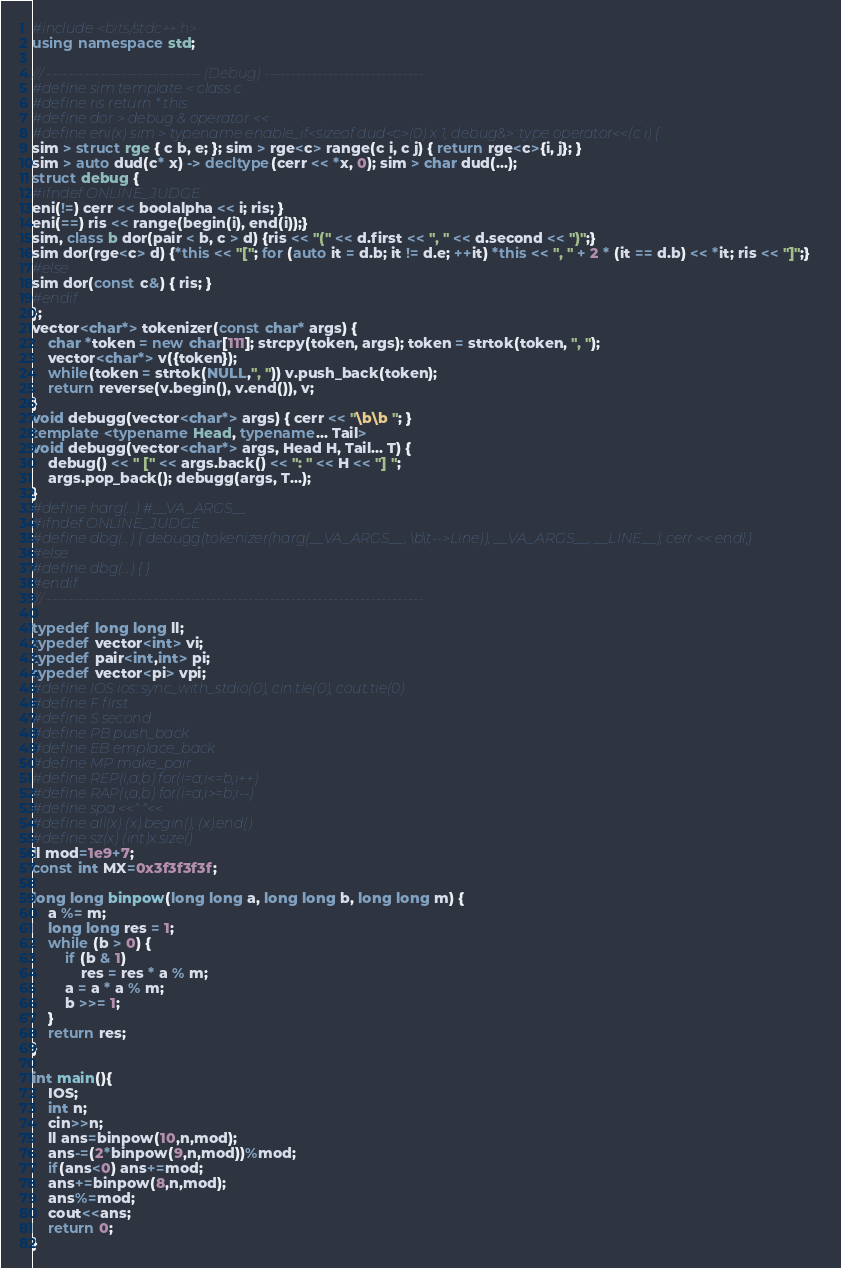<code> <loc_0><loc_0><loc_500><loc_500><_C++_>#include<bits/stdc++.h>
using namespace std;
 
/// ----------------------------- (Debug) ------------------------------
#define sim template < class c
#define ris return * this
#define dor > debug & operator <<
#define eni(x) sim > typename enable_if<sizeof dud<c>(0) x 1, debug&>::type operator<<(c i) {
sim > struct rge { c b, e; }; sim > rge<c> range(c i, c j) { return rge<c>{i, j}; }
sim > auto dud(c* x) -> decltype(cerr << *x, 0); sim > char dud(...);
struct debug {
#ifndef ONLINE_JUDGE
eni(!=) cerr << boolalpha << i; ris; }
eni(==) ris << range(begin(i), end(i));}
sim, class b dor(pair < b, c > d) {ris << "(" << d.first << ", " << d.second << ")";}
sim dor(rge<c> d) {*this << "["; for (auto it = d.b; it != d.e; ++it) *this << ", " + 2 * (it == d.b) << *it; ris << "]";}
#else
sim dor(const c&) { ris; }
#endif
};
vector<char*> tokenizer(const char* args) {
    char *token = new char[111]; strcpy(token, args); token = strtok(token, ", ");
    vector<char*> v({token});
    while(token = strtok(NULL,", ")) v.push_back(token);
    return reverse(v.begin(), v.end()), v;
}
void debugg(vector<char*> args) { cerr << "\b\b "; }
template <typename Head, typename... Tail>
void debugg(vector<char*> args, Head H, Tail... T) {
    debug() << " [" << args.back() << ": " << H << "] ";
    args.pop_back(); debugg(args, T...);
}
#define harg(...) #__VA_ARGS__
#ifndef ONLINE_JUDGE
#define dbg(...) { debugg(tokenizer(harg(__VA_ARGS__, \b\t-->Line)), __VA_ARGS__, __LINE__); cerr << endl;}
#else
#define dbg(...) { }
#endif
/// -----------------------------------------------------------------------
 
typedef long long ll;
typedef vector<int> vi;
typedef pair<int,int> pi;
typedef vector<pi> vpi; 
#define IOS ios::sync_with_stdio(0); cin.tie(0); cout.tie(0)    
#define F first
#define S second
#define PB push_back
#define EB emplace_back
#define MP make_pair
#define REP(i,a,b) for(i=a;i<=b;i++)
#define RAP(i,a,b) for(i=a;i>=b;i--)
#define spa <<" "<<
#define all(x) (x).begin(), (x).end()
#define sz(x) (int)x.size()
ll mod=1e9+7;
const int MX=0x3f3f3f3f;

long long binpow(long long a, long long b, long long m) {
    a %= m;
    long long res = 1;
    while (b > 0) {
        if (b & 1)
            res = res * a % m;
        a = a * a % m;
        b >>= 1;
    }
    return res;
}

int main(){
    IOS;
    int n;
    cin>>n;
    ll ans=binpow(10,n,mod);
    ans-=(2*binpow(9,n,mod))%mod;
    if(ans<0) ans+=mod;
    ans+=binpow(8,n,mod);
    ans%=mod;
    cout<<ans;
    return 0;
}</code> 